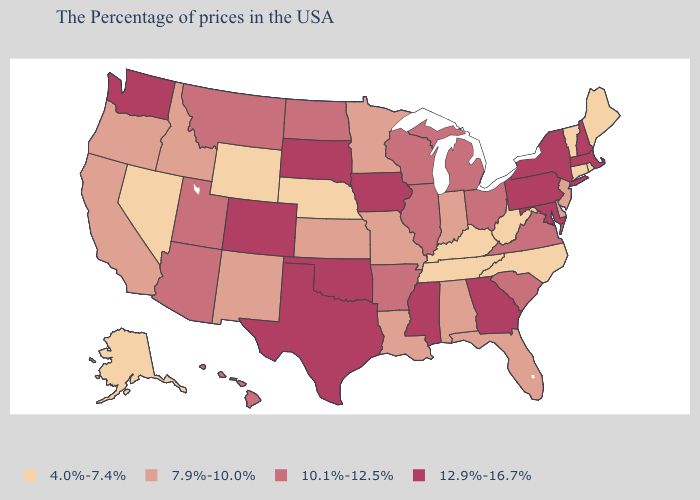Is the legend a continuous bar?
Quick response, please. No. Name the states that have a value in the range 10.1%-12.5%?
Write a very short answer. Virginia, South Carolina, Ohio, Michigan, Wisconsin, Illinois, Arkansas, North Dakota, Utah, Montana, Arizona, Hawaii. Name the states that have a value in the range 4.0%-7.4%?
Quick response, please. Maine, Rhode Island, Vermont, Connecticut, North Carolina, West Virginia, Kentucky, Tennessee, Nebraska, Wyoming, Nevada, Alaska. Does New Hampshire have the same value as Colorado?
Be succinct. Yes. Is the legend a continuous bar?
Quick response, please. No. What is the value of Illinois?
Keep it brief. 10.1%-12.5%. Name the states that have a value in the range 12.9%-16.7%?
Concise answer only. Massachusetts, New Hampshire, New York, Maryland, Pennsylvania, Georgia, Mississippi, Iowa, Oklahoma, Texas, South Dakota, Colorado, Washington. What is the highest value in the USA?
Short answer required. 12.9%-16.7%. Which states have the lowest value in the USA?
Concise answer only. Maine, Rhode Island, Vermont, Connecticut, North Carolina, West Virginia, Kentucky, Tennessee, Nebraska, Wyoming, Nevada, Alaska. Does North Dakota have a lower value than Kansas?
Keep it brief. No. Which states have the lowest value in the MidWest?
Be succinct. Nebraska. What is the value of New Mexico?
Keep it brief. 7.9%-10.0%. What is the lowest value in the USA?
Concise answer only. 4.0%-7.4%. Which states have the lowest value in the USA?
Write a very short answer. Maine, Rhode Island, Vermont, Connecticut, North Carolina, West Virginia, Kentucky, Tennessee, Nebraska, Wyoming, Nevada, Alaska. What is the value of Indiana?
Answer briefly. 7.9%-10.0%. 